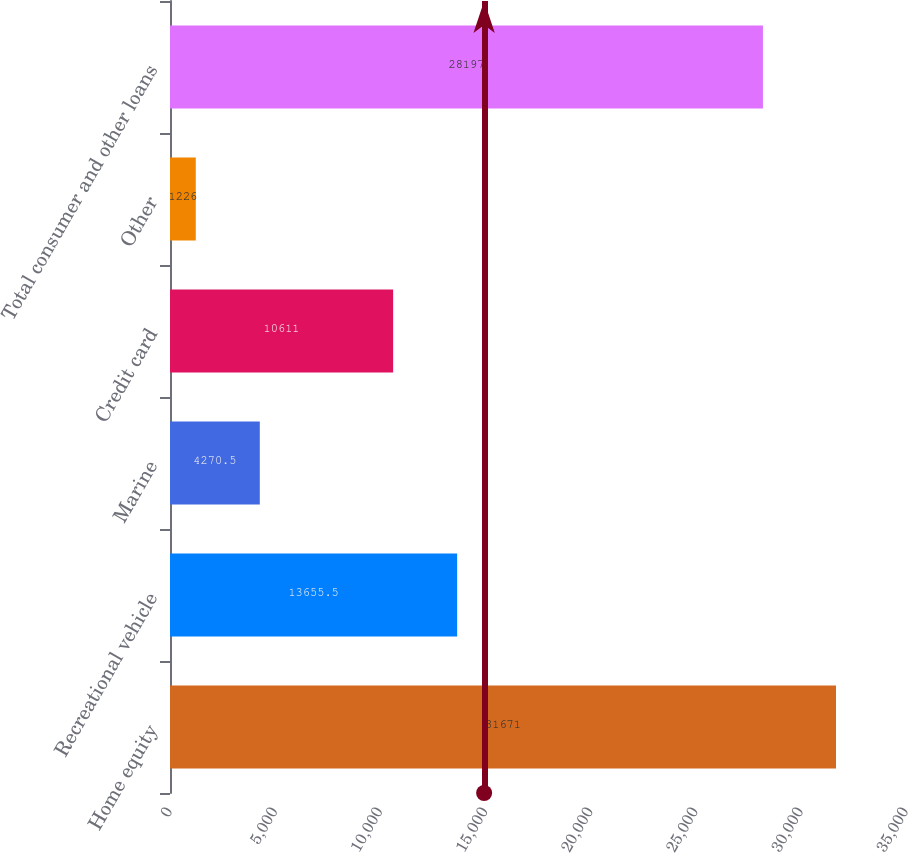<chart> <loc_0><loc_0><loc_500><loc_500><bar_chart><fcel>Home equity<fcel>Recreational vehicle<fcel>Marine<fcel>Credit card<fcel>Other<fcel>Total consumer and other loans<nl><fcel>31671<fcel>13655.5<fcel>4270.5<fcel>10611<fcel>1226<fcel>28197<nl></chart> 